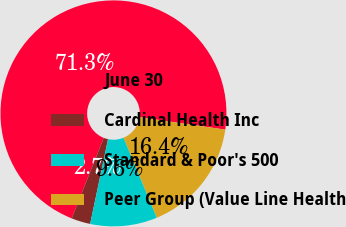Convert chart to OTSL. <chart><loc_0><loc_0><loc_500><loc_500><pie_chart><fcel>June 30<fcel>Cardinal Health Inc<fcel>Standard & Poor's 500<fcel>Peer Group (Value Line Health<nl><fcel>71.27%<fcel>2.72%<fcel>9.58%<fcel>16.43%<nl></chart> 